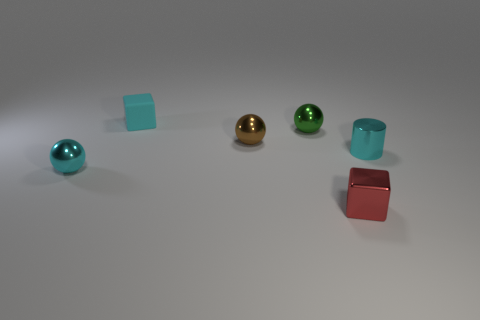Is there anything else that has the same material as the cyan block?
Keep it short and to the point. No. Are there an equal number of small cyan metal cylinders that are behind the rubber cube and brown metallic things on the right side of the metal cylinder?
Provide a short and direct response. Yes. How many big brown cylinders have the same material as the tiny brown sphere?
Keep it short and to the point. 0. There is a small metal thing that is the same color as the tiny cylinder; what shape is it?
Provide a succinct answer. Sphere. What is the size of the metal thing that is in front of the small sphere that is on the left side of the tiny cyan matte object?
Provide a short and direct response. Small. There is a tiny cyan thing on the left side of the small rubber thing; is its shape the same as the cyan metallic thing right of the tiny cyan shiny sphere?
Your answer should be very brief. No. Is the number of tiny cyan shiny objects on the left side of the cyan cube the same as the number of small matte blocks?
Give a very brief answer. Yes. There is another object that is the same shape as the cyan matte object; what color is it?
Your response must be concise. Red. Do the cyan thing that is in front of the small cyan cylinder and the green thing have the same material?
Provide a short and direct response. Yes. How many large objects are red rubber objects or metallic balls?
Provide a short and direct response. 0. 